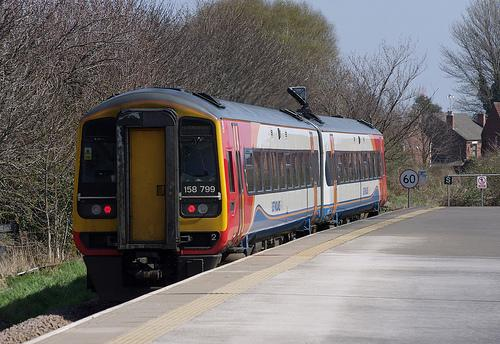Do you think the train is about to depart or has it just arrived, and why? It could be either; there is no clear indication of whether the train has just arrived or is about to depart based on the information in the image. Describe any potential interactions between objects in the image. Passengers may walk on the platform to reach the waiting area, and then board the train using the front door. Identify the main object in the image and provide a brief description of it. A short passenger train, predominantly white with red and blue accents, is parked on the track beside the platform. Count the number of windows in the train. There are 12 windows visible on the side of the train. Assess the quality of the image in terms of clarity and composition. The image is of high quality, with clear and detailed object representations and a well-composed scene including the train and its surroundings. What type of train is in the image? Mention any additional features that stand out. It is a short passenger train with a distinctive front design, red and blue accents, and an antenna on top. List down the key features of the train. Short length, predominantly white color with red and blue accents, distinctive front design, antenna on top, front door, and windows. What do the signs near the train say? The signs near the train include a white sign with black numbers and a round white sign with red trim. Analyze the emotions or atmosphere of the image. The atmosphere of the image seems calm and peaceful, as the train is parked in a serene environment with some trees and a clear sky. Describe the setting around the train. The train is parked beside a platform, with trees lining the tracks, a sidewalk, and a house in the background. 